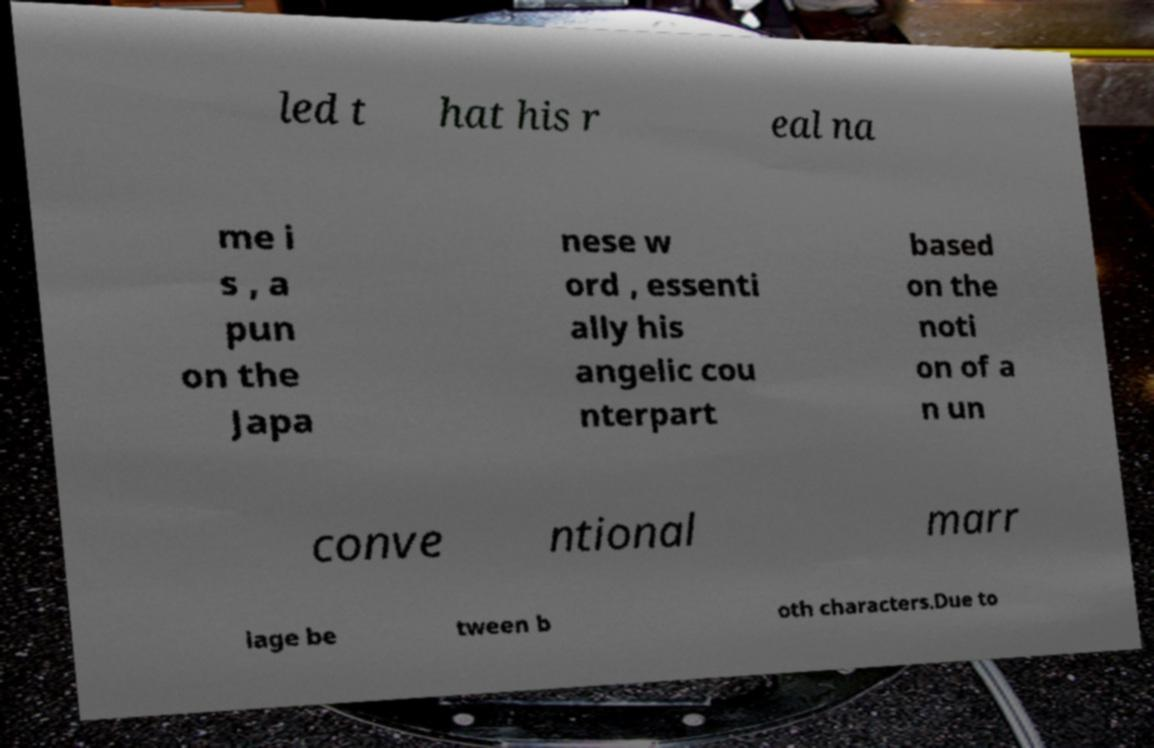Can you read and provide the text displayed in the image?This photo seems to have some interesting text. Can you extract and type it out for me? led t hat his r eal na me i s , a pun on the Japa nese w ord , essenti ally his angelic cou nterpart based on the noti on of a n un conve ntional marr iage be tween b oth characters.Due to 